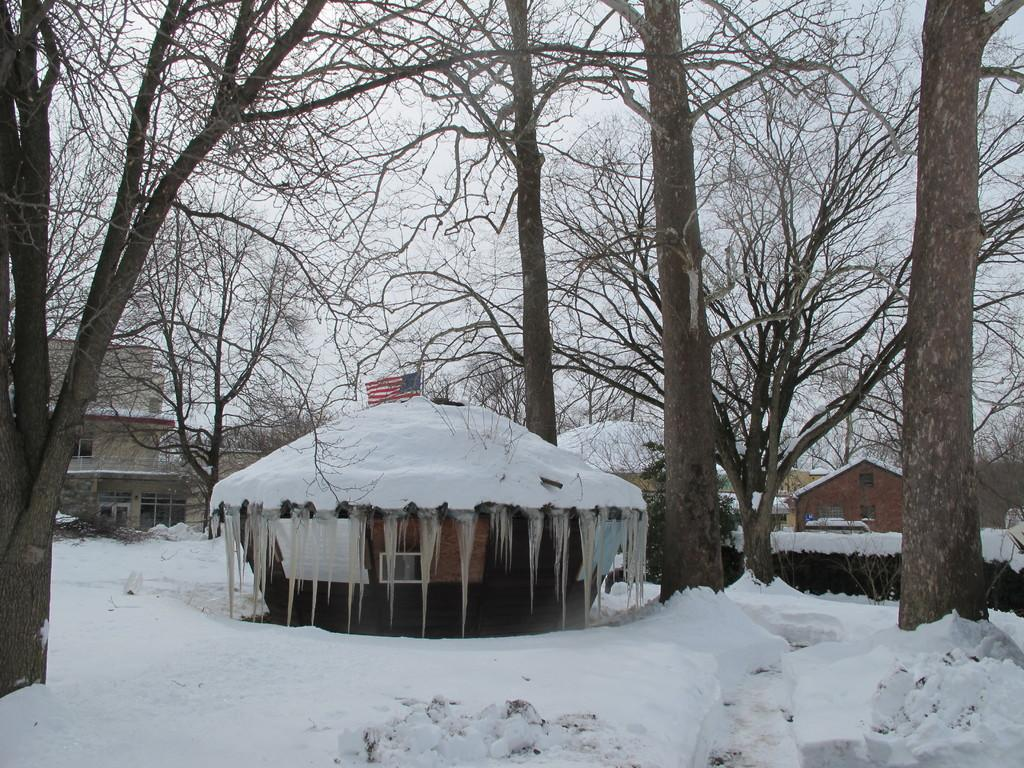What type of structures can be seen in the image? There are houses and buildings in the image. What is the weather like in the image? There is snow visible in the background of the image, indicating a cold or wintry weather. What else can be seen in the background of the image? There is a flag, trees, and the sky visible in the background of the image. What color is the queen's dress in the image? There is no queen present in the image, so it is not possible to determine the color of her dress. 